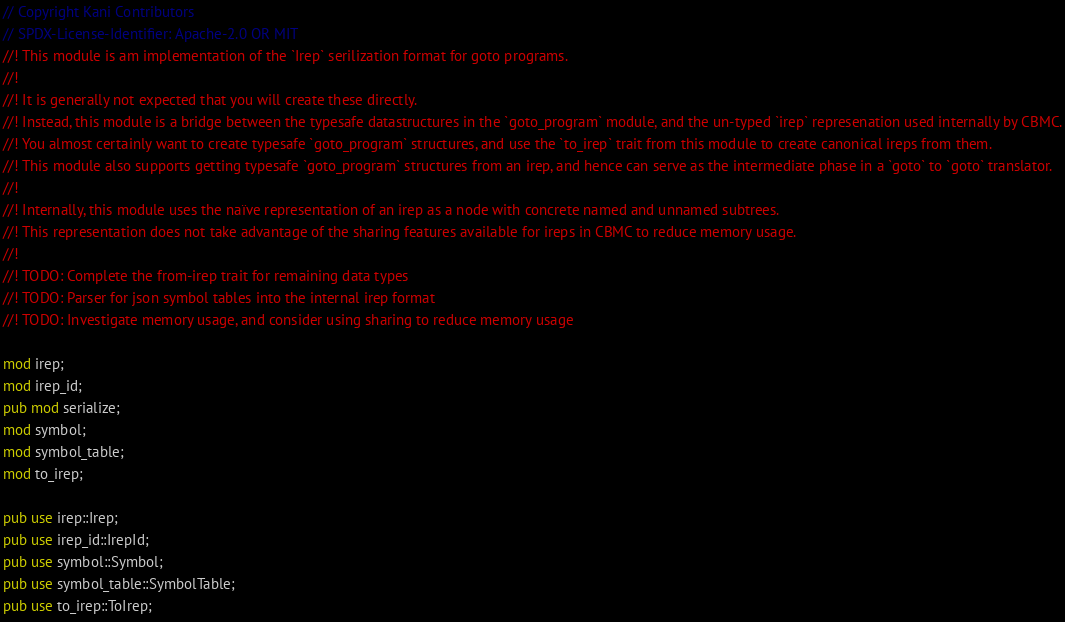<code> <loc_0><loc_0><loc_500><loc_500><_Rust_>// Copyright Kani Contributors
// SPDX-License-Identifier: Apache-2.0 OR MIT
//! This module is am implementation of the `Irep` serilization format for goto programs.
//!
//! It is generally not expected that you will create these directly.
//! Instead, this module is a bridge between the typesafe datastructures in the `goto_program` module, and the un-typed `irep` represenation used internally by CBMC.
//! You almost certainly want to create typesafe `goto_program` structures, and use the `to_irep` trait from this module to create canonical ireps from them.
//! This module also supports getting typesafe `goto_program` structures from an irep, and hence can serve as the intermediate phase in a `goto` to `goto` translator.
//!
//! Internally, this module uses the naïve representation of an irep as a node with concrete named and unnamed subtrees.
//! This representation does not take advantage of the sharing features available for ireps in CBMC to reduce memory usage.
//!
//! TODO: Complete the from-irep trait for remaining data types
//! TODO: Parser for json symbol tables into the internal irep format
//! TODO: Investigate memory usage, and consider using sharing to reduce memory usage

mod irep;
mod irep_id;
pub mod serialize;
mod symbol;
mod symbol_table;
mod to_irep;

pub use irep::Irep;
pub use irep_id::IrepId;
pub use symbol::Symbol;
pub use symbol_table::SymbolTable;
pub use to_irep::ToIrep;
</code> 